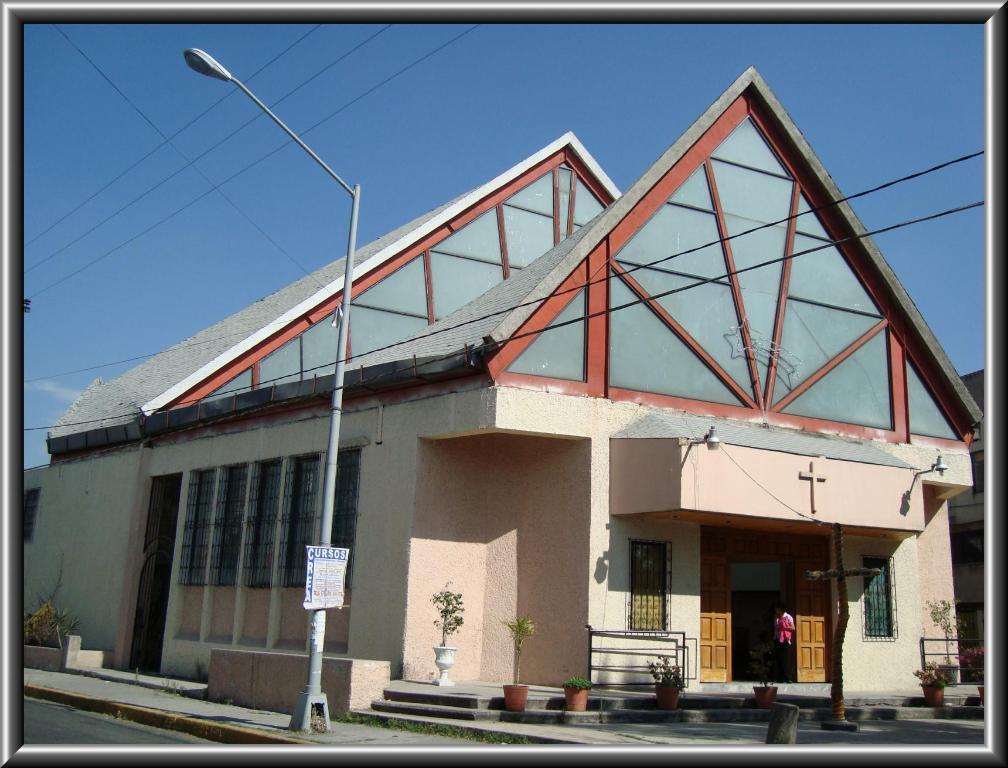In one or two sentences, can you explain what this image depicts? In this image I can see a street light. I can see a house. At the top I can see the sky. 